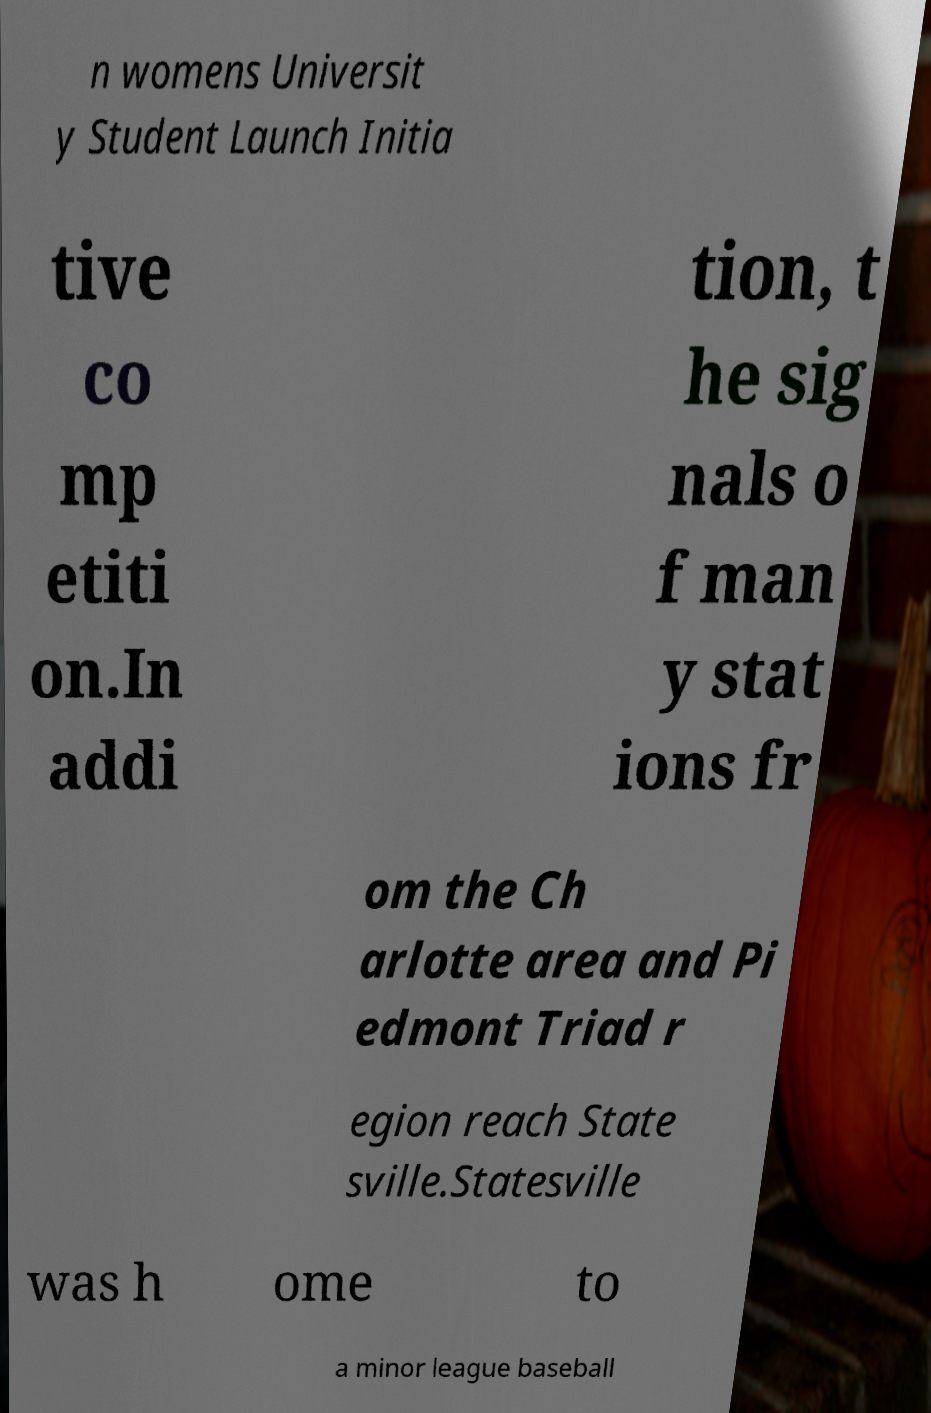There's text embedded in this image that I need extracted. Can you transcribe it verbatim? n womens Universit y Student Launch Initia tive co mp etiti on.In addi tion, t he sig nals o f man y stat ions fr om the Ch arlotte area and Pi edmont Triad r egion reach State sville.Statesville was h ome to a minor league baseball 